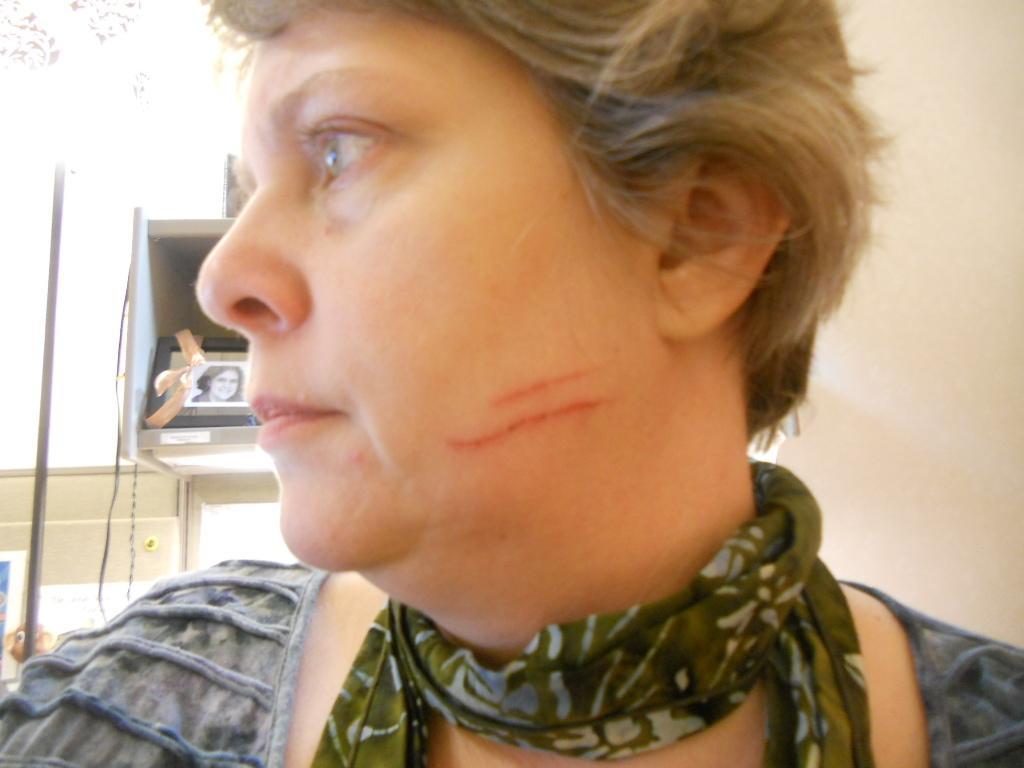Describe this image in one or two sentences. In this image I can see a person wearing different color dress. Back I can see few objects and frame. Background is in white color. 